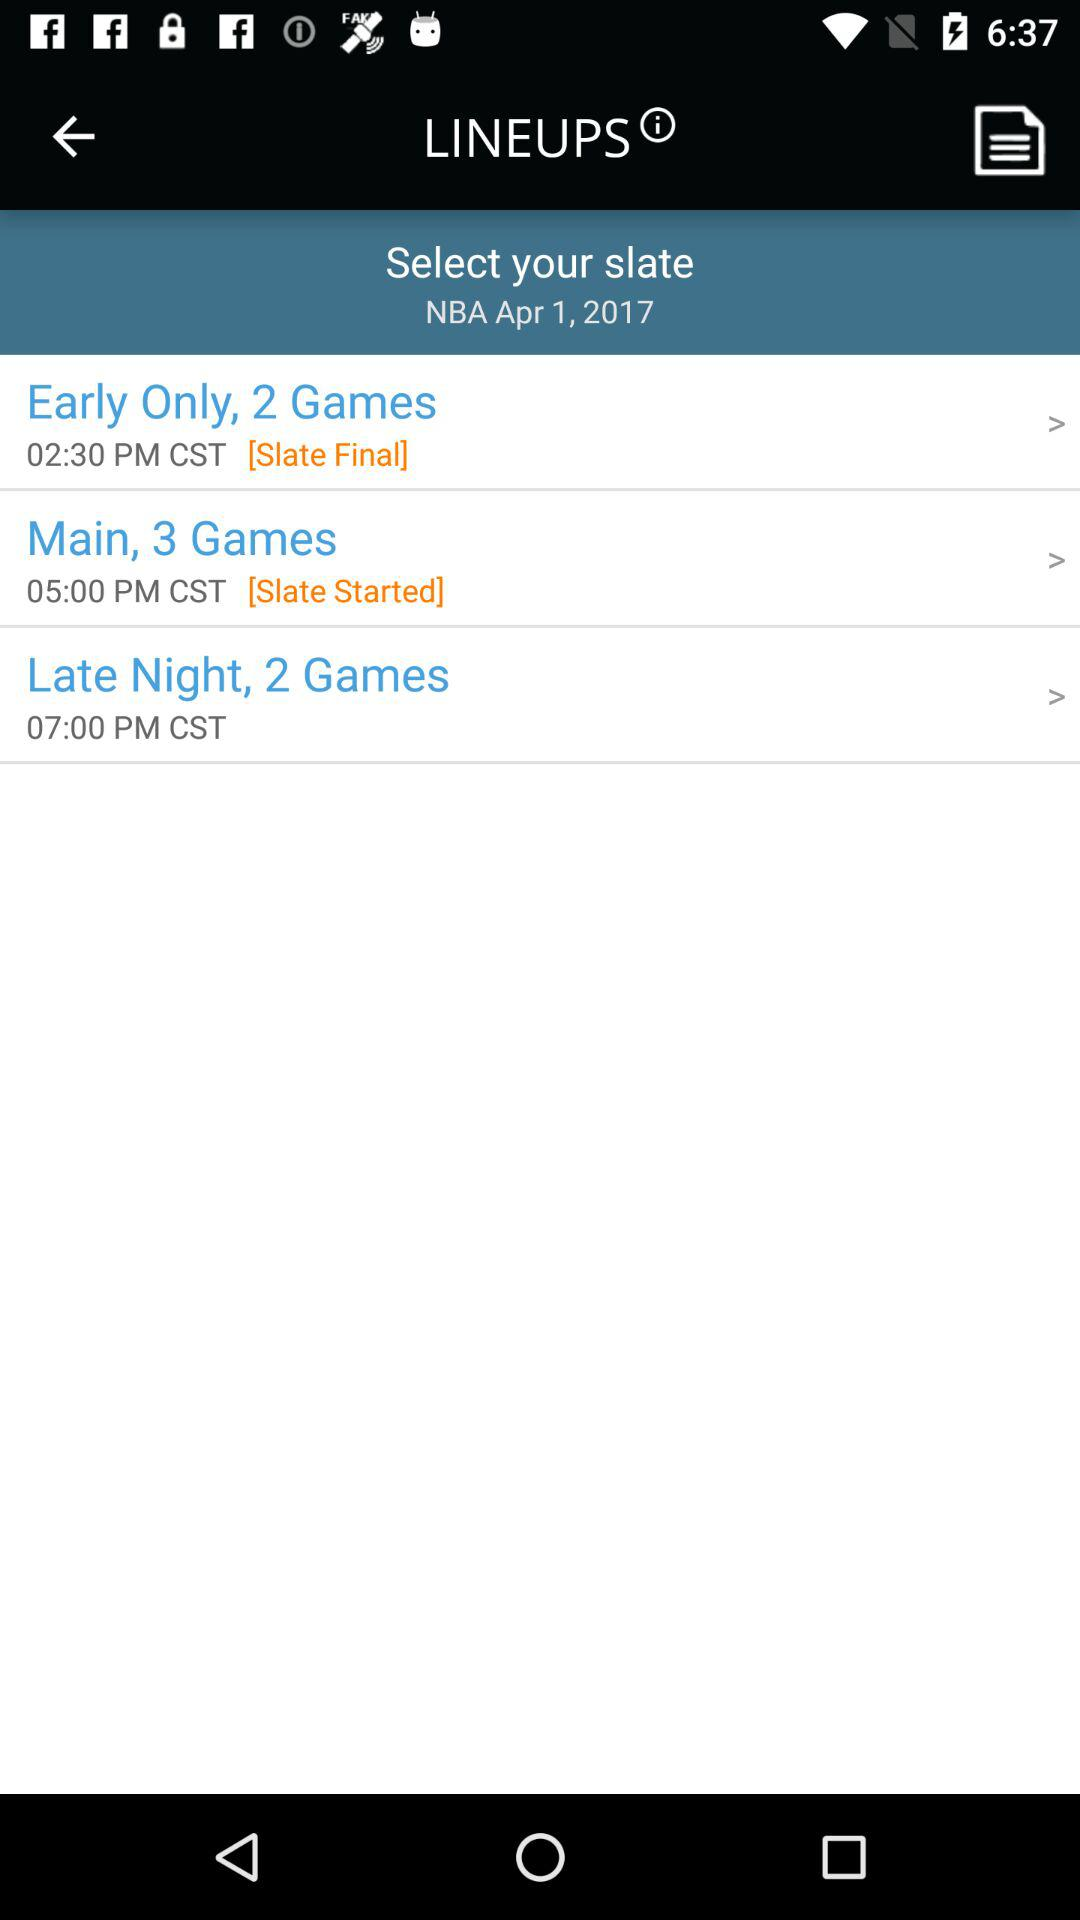How many games are in the Early Only slate?
Answer the question using a single word or phrase. 2 